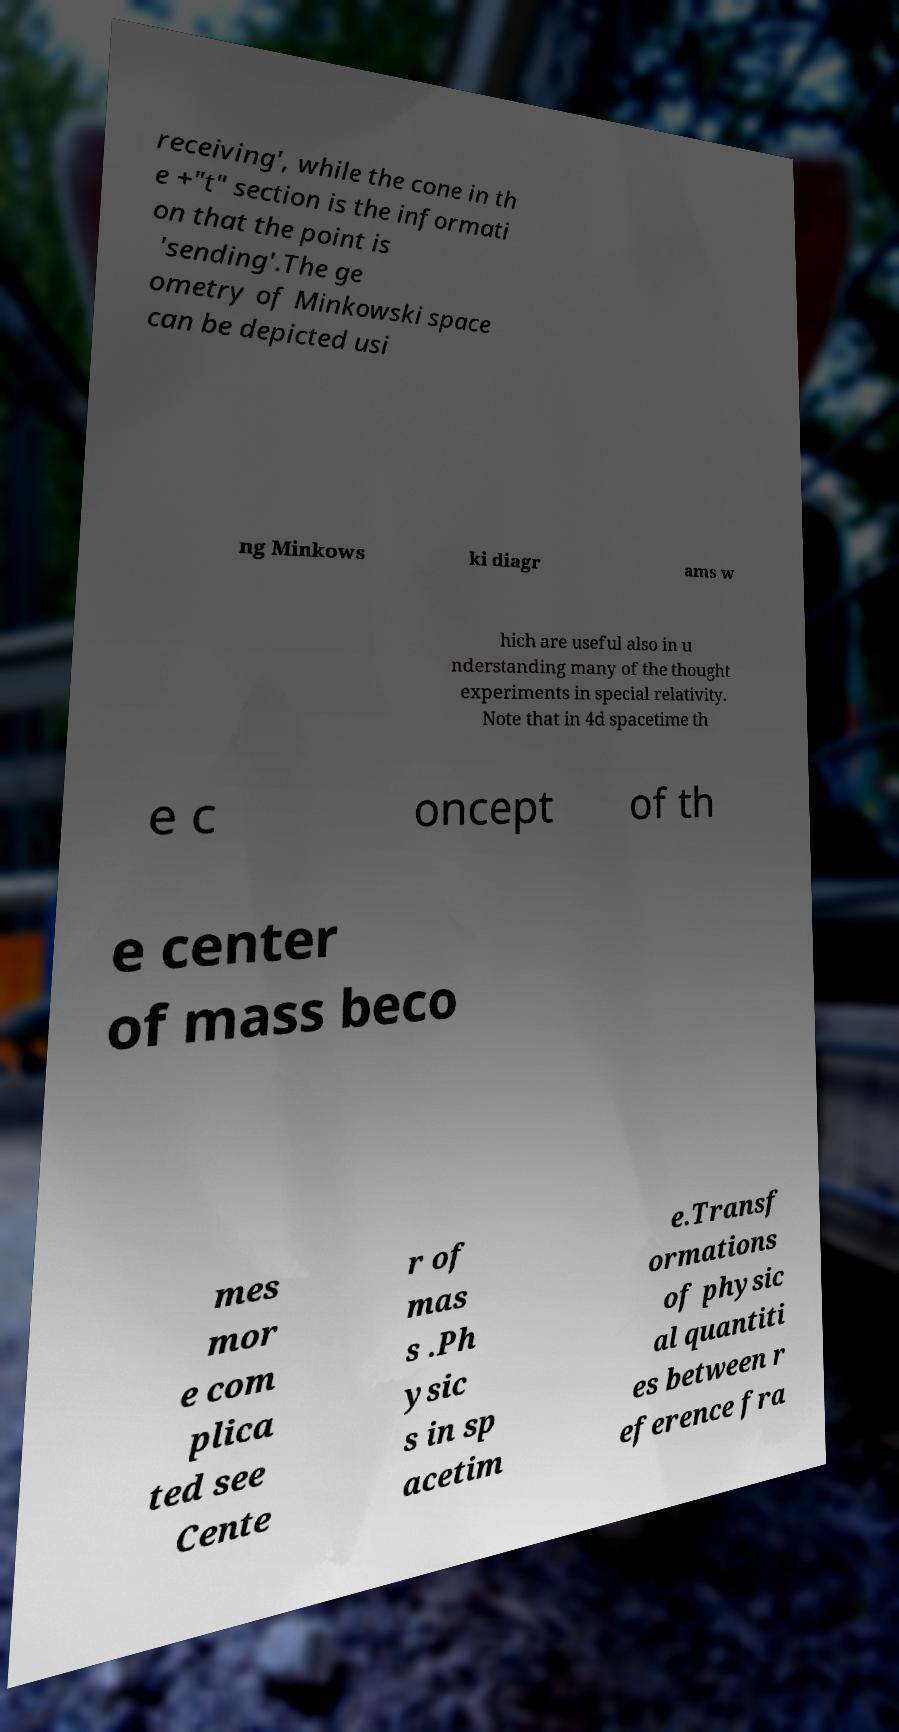I need the written content from this picture converted into text. Can you do that? receiving', while the cone in th e +"t" section is the informati on that the point is 'sending'.The ge ometry of Minkowski space can be depicted usi ng Minkows ki diagr ams w hich are useful also in u nderstanding many of the thought experiments in special relativity. Note that in 4d spacetime th e c oncept of th e center of mass beco mes mor e com plica ted see Cente r of mas s .Ph ysic s in sp acetim e.Transf ormations of physic al quantiti es between r eference fra 